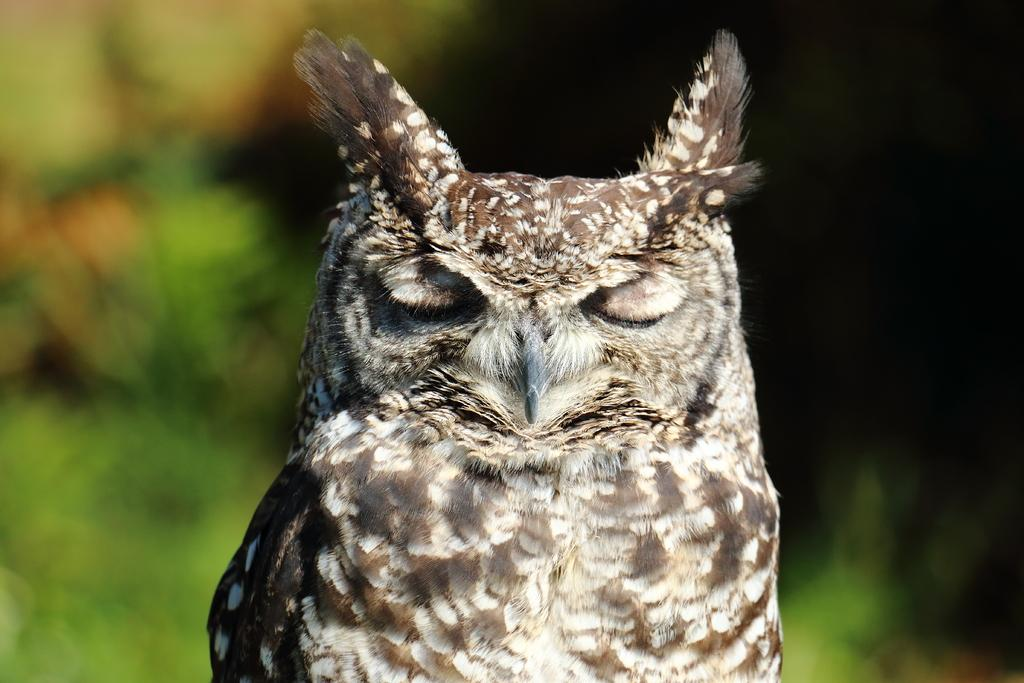What shape can be seen in the image? There is an oval shape in the image. Can you describe the background of the image? The background of the image is blurred. How many kittens are sitting on the leaf in the image? There are no kittens or leaves present in the image. Who is the creator of the oval shape in the image? The creator of the oval shape in the image is not mentioned or visible in the image. 